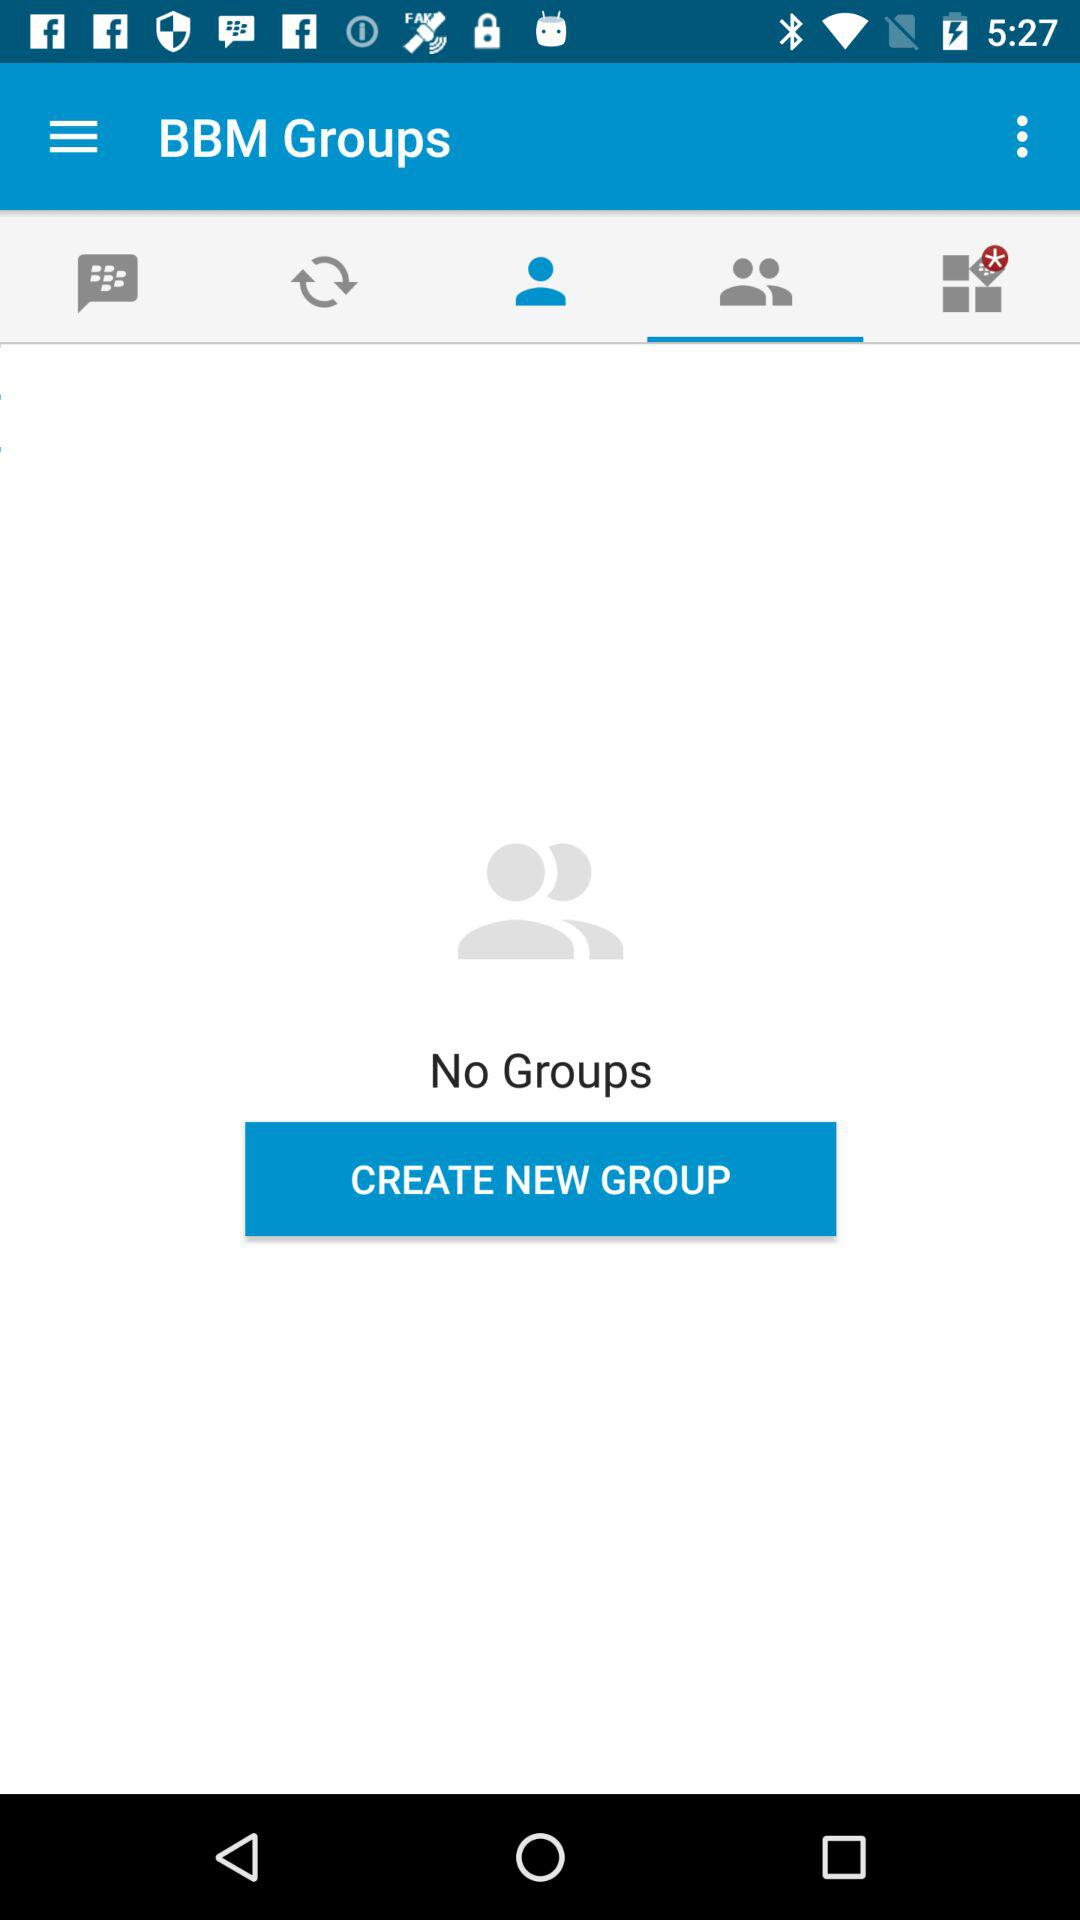What is the application name? The application name is "BBM Groups". 